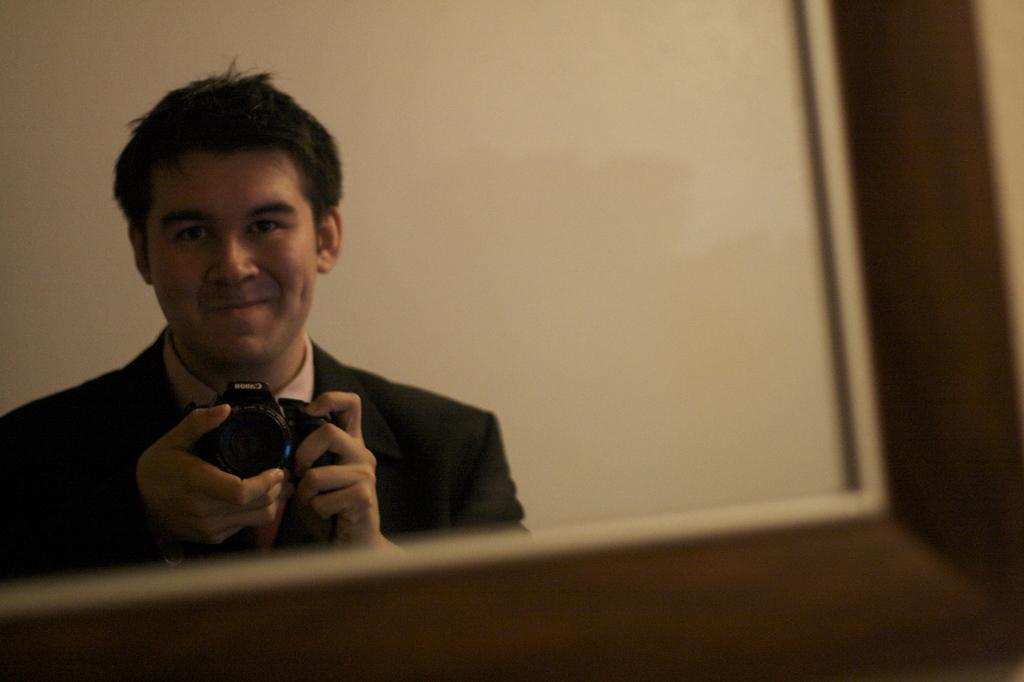What is the main subject of the image? The main subject of the image is a man. What is the man holding in the image? The man is holding a camera with his hands. What is the man's facial expression in the image? The man is smiling in the image. What can be seen in the background of the image? There is a wall in the background of the image. What type of wrench is the man using to adjust the camera in the image? There is no wrench present in the image, and the man is not adjusting the camera. 